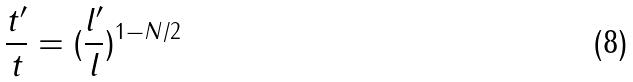Convert formula to latex. <formula><loc_0><loc_0><loc_500><loc_500>\frac { t ^ { \prime } } { t } = ( \frac { l ^ { \prime } } { l } ) ^ { 1 - N / 2 }</formula> 